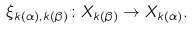Convert formula to latex. <formula><loc_0><loc_0><loc_500><loc_500>\xi _ { k ( \alpha ) , k ( \beta ) } \colon X _ { k ( \beta ) } \to X _ { k ( \alpha ) } .</formula> 